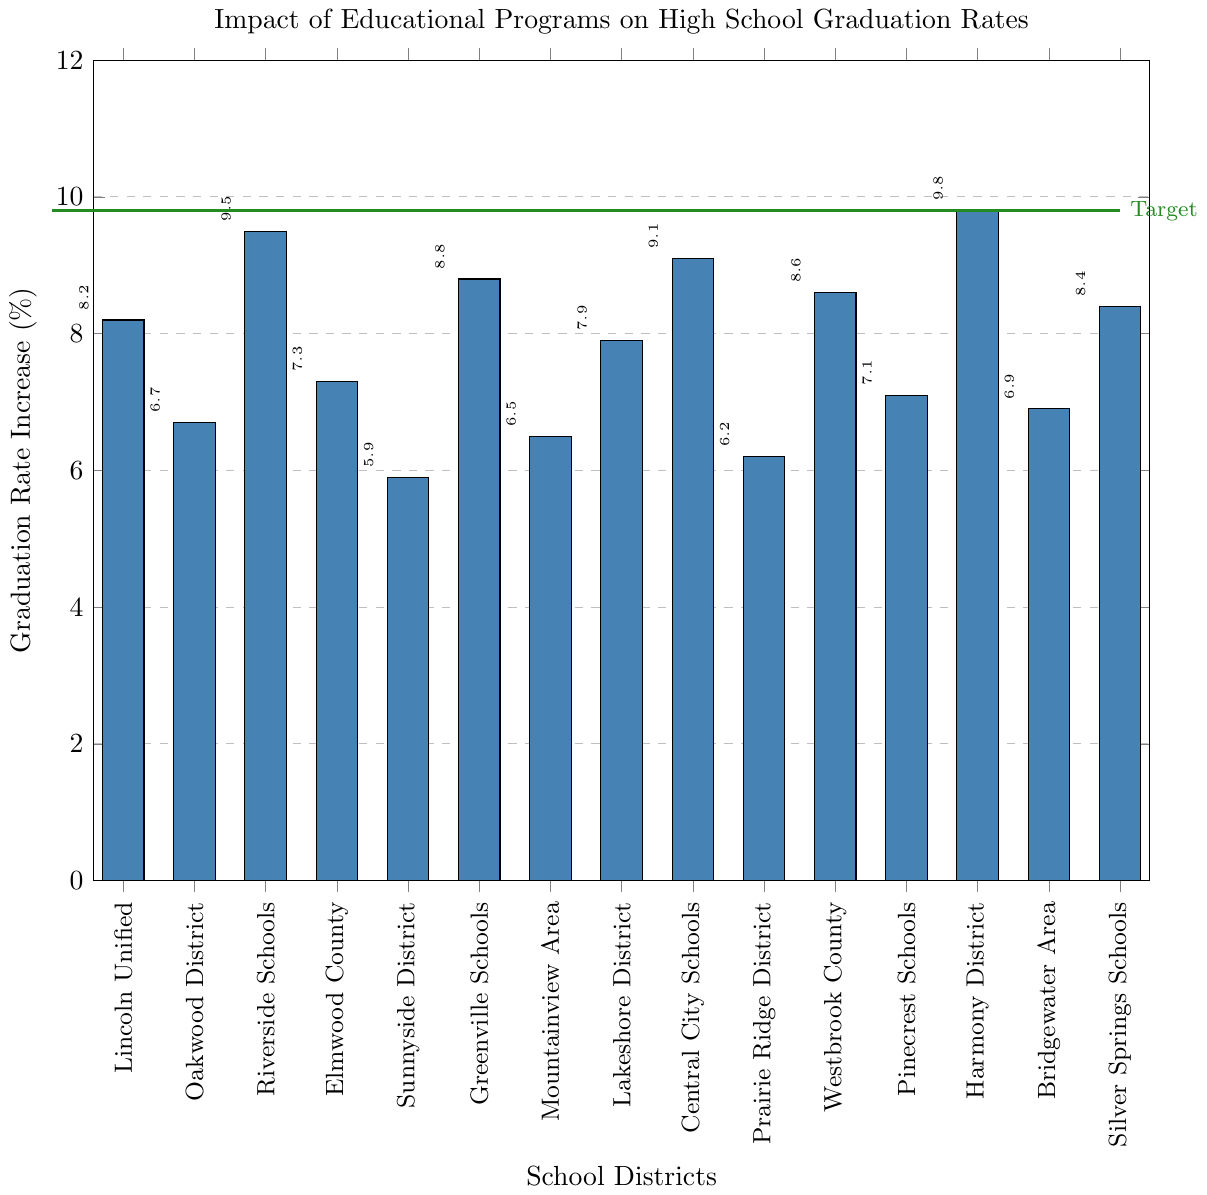What's the highest graduation rate increase among the districts? Identify the tallest bar in the bar chart and check the y-axis label for the corresponding increase percentage.
Answer: 9.8% Which district has the highest graduation rate increase? Locate the tallest bar in the chart and refer to the x-axis label to find the district name.
Answer: Harmony District How many districts achieved a graduation rate increase of 8% or more? Identify all bars that extend to 8% or higher on the y-axis and count them.
Answer: 7 What is the total graduation rate increase for Oakwood District and Westbrook County combined? Find the individual values for Oakwood District (6.7%) and Westbrook County (8.6%), then sum them: 6.7 + 8.6.
Answer: 15.3% What is the difference in graduation rate increase between Riverside Schools and Sunnyside District? Identify the graduation rates for Riverside Schools (9.5%) and Sunnyside District (5.9%), then subtract the smaller value from the larger: 9.5 - 5.9.
Answer: 3.6% Which districts have a graduation rate increase less than 7%? Identify all bars with heights less than 7% and refer to the x-axis labels for the district names.
Answer: Oakwood District, Sunnyside District, Mountainview Area, Prairie Ridge District, Bridgewater Area What is the average graduation rate increase across all districts? Sum the graduation rate increases for all districts and divide by the number of districts. (8.2 + 6.7 + 9.5 + 7.3 + 5.9 + 8.8 + 6.5 + 7.9 + 9.1 + 6.2 + 8.6 + 7.1 + 9.8 + 6.9 + 8.4) / 15.
Answer: 7.79% How many districts are above the target graduation rate increase line? Identify the number of bars that are higher than the target line drawn at 9.8%.
Answer: 1 Are more districts below or above the target graduation rate increase of 9.8%? Count the number of bars above and below the target line at 9.8% and compare the counts.
Answer: Below Which district has the second-highest graduation rate increase? Identify the second tallest bar in the chart and check the corresponding district name on the x-axis.
Answer: Riverside Schools 